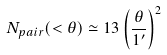<formula> <loc_0><loc_0><loc_500><loc_500>N _ { p a i r } ( < \theta ) \simeq 1 3 \left ( \frac { \theta } { 1 ^ { \prime } } \right ) ^ { 2 }</formula> 